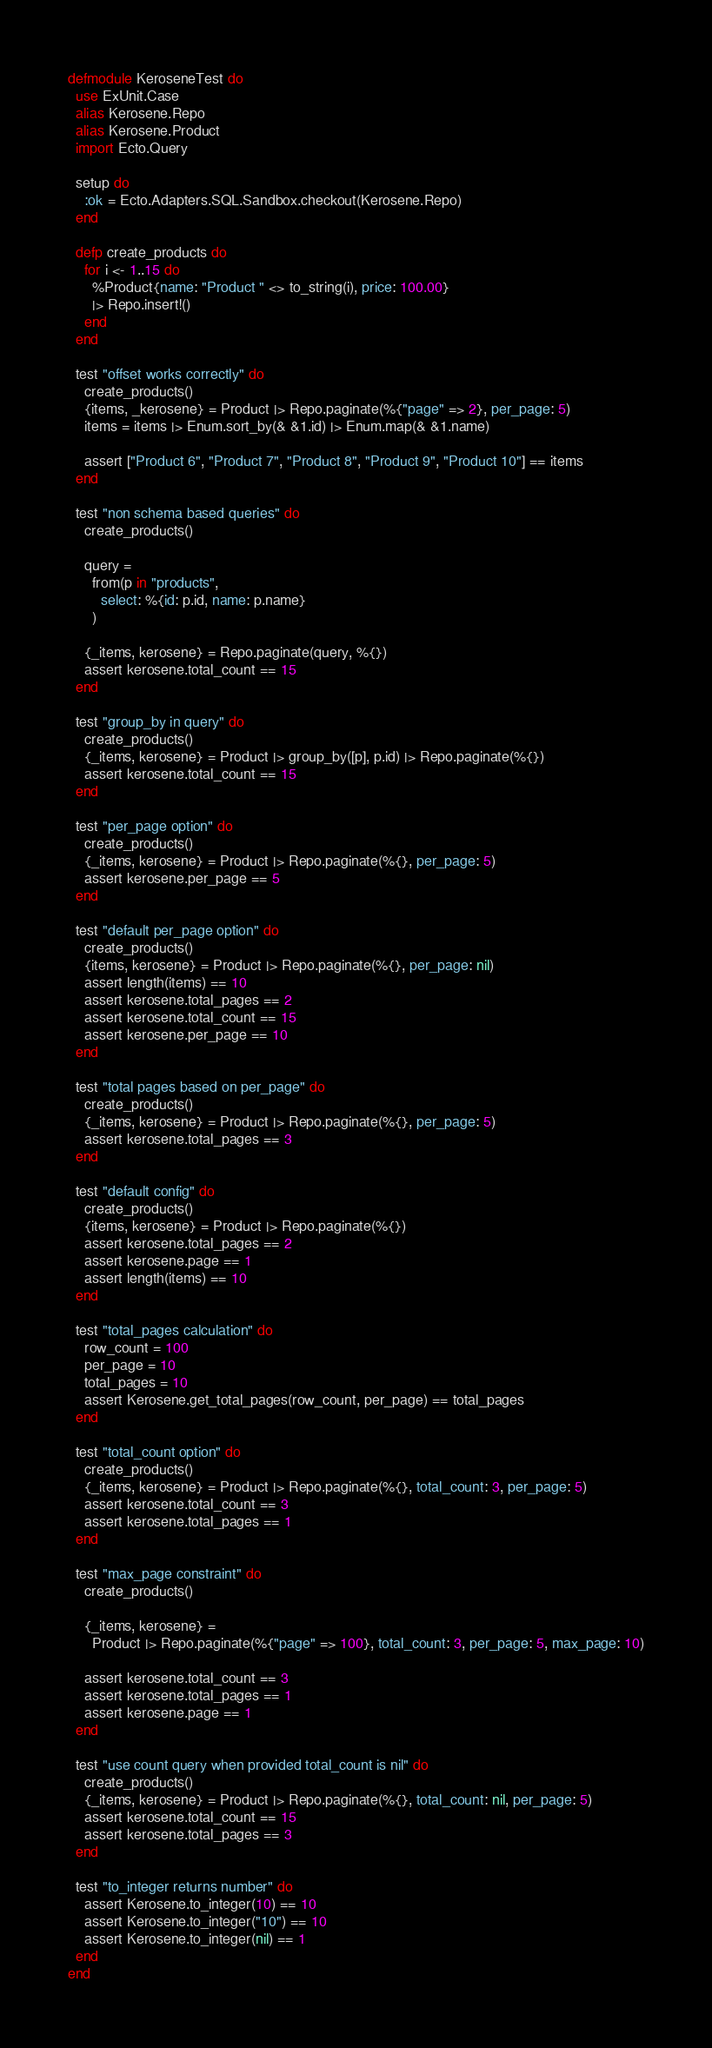Convert code to text. <code><loc_0><loc_0><loc_500><loc_500><_Elixir_>defmodule KeroseneTest do
  use ExUnit.Case
  alias Kerosene.Repo
  alias Kerosene.Product
  import Ecto.Query

  setup do
    :ok = Ecto.Adapters.SQL.Sandbox.checkout(Kerosene.Repo)
  end

  defp create_products do
    for i <- 1..15 do
      %Product{name: "Product " <> to_string(i), price: 100.00}
      |> Repo.insert!()
    end
  end

  test "offset works correctly" do
    create_products()
    {items, _kerosene} = Product |> Repo.paginate(%{"page" => 2}, per_page: 5)
    items = items |> Enum.sort_by(& &1.id) |> Enum.map(& &1.name)

    assert ["Product 6", "Product 7", "Product 8", "Product 9", "Product 10"] == items
  end

  test "non schema based queries" do
    create_products()

    query =
      from(p in "products",
        select: %{id: p.id, name: p.name}
      )

    {_items, kerosene} = Repo.paginate(query, %{})
    assert kerosene.total_count == 15
  end

  test "group_by in query" do
    create_products()
    {_items, kerosene} = Product |> group_by([p], p.id) |> Repo.paginate(%{})
    assert kerosene.total_count == 15
  end

  test "per_page option" do
    create_products()
    {_items, kerosene} = Product |> Repo.paginate(%{}, per_page: 5)
    assert kerosene.per_page == 5
  end

  test "default per_page option" do
    create_products()
    {items, kerosene} = Product |> Repo.paginate(%{}, per_page: nil)
    assert length(items) == 10
    assert kerosene.total_pages == 2
    assert kerosene.total_count == 15
    assert kerosene.per_page == 10
  end

  test "total pages based on per_page" do
    create_products()
    {_items, kerosene} = Product |> Repo.paginate(%{}, per_page: 5)
    assert kerosene.total_pages == 3
  end

  test "default config" do
    create_products()
    {items, kerosene} = Product |> Repo.paginate(%{})
    assert kerosene.total_pages == 2
    assert kerosene.page == 1
    assert length(items) == 10
  end

  test "total_pages calculation" do
    row_count = 100
    per_page = 10
    total_pages = 10
    assert Kerosene.get_total_pages(row_count, per_page) == total_pages
  end

  test "total_count option" do
    create_products()
    {_items, kerosene} = Product |> Repo.paginate(%{}, total_count: 3, per_page: 5)
    assert kerosene.total_count == 3
    assert kerosene.total_pages == 1
  end

  test "max_page constraint" do
    create_products()

    {_items, kerosene} =
      Product |> Repo.paginate(%{"page" => 100}, total_count: 3, per_page: 5, max_page: 10)

    assert kerosene.total_count == 3
    assert kerosene.total_pages == 1
    assert kerosene.page == 1
  end

  test "use count query when provided total_count is nil" do
    create_products()
    {_items, kerosene} = Product |> Repo.paginate(%{}, total_count: nil, per_page: 5)
    assert kerosene.total_count == 15
    assert kerosene.total_pages == 3
  end

  test "to_integer returns number" do
    assert Kerosene.to_integer(10) == 10
    assert Kerosene.to_integer("10") == 10
    assert Kerosene.to_integer(nil) == 1
  end
end
</code> 